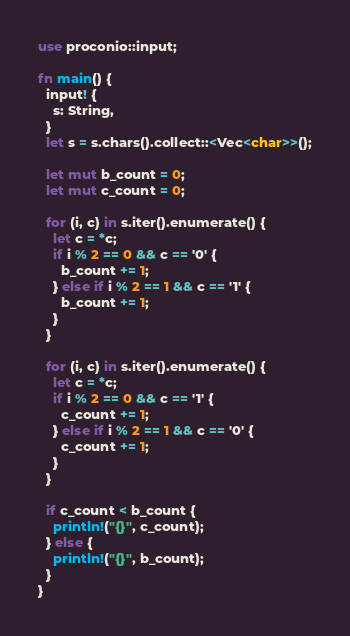<code> <loc_0><loc_0><loc_500><loc_500><_Rust_>use proconio::input;

fn main() {
  input! {
    s: String,
  }
  let s = s.chars().collect::<Vec<char>>();
  
  let mut b_count = 0;
  let mut c_count = 0;
  
  for (i, c) in s.iter().enumerate() {
    let c = *c;
    if i % 2 == 0 && c == '0' {
      b_count += 1;
    } else if i % 2 == 1 && c == '1' {
      b_count += 1;
    }
  }
  
  for (i, c) in s.iter().enumerate() {
    let c = *c;
    if i % 2 == 0 && c == '1' {
      c_count += 1;
    } else if i % 2 == 1 && c == '0' {
      c_count += 1;
    }
  }
  
  if c_count < b_count {
    println!("{}", c_count);
  } else {
    println!("{}", b_count);
  }
}</code> 